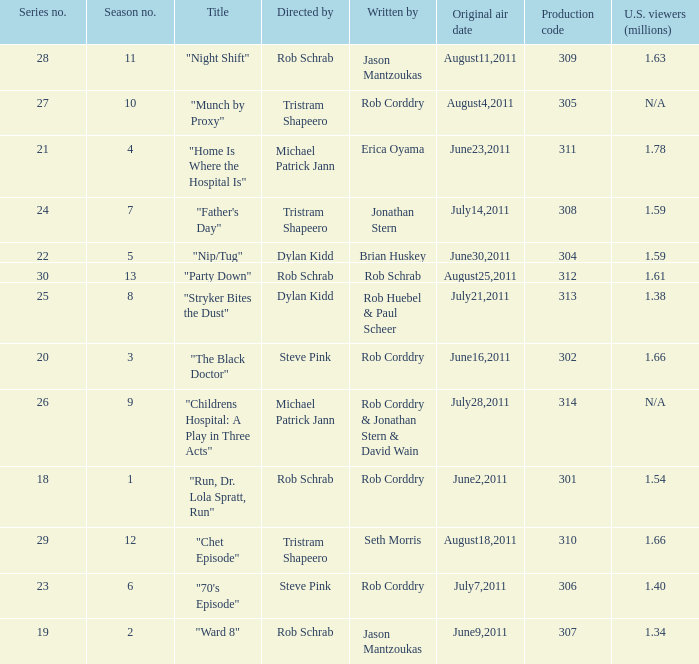At most what number in the series was the episode "chet episode"? 29.0. 